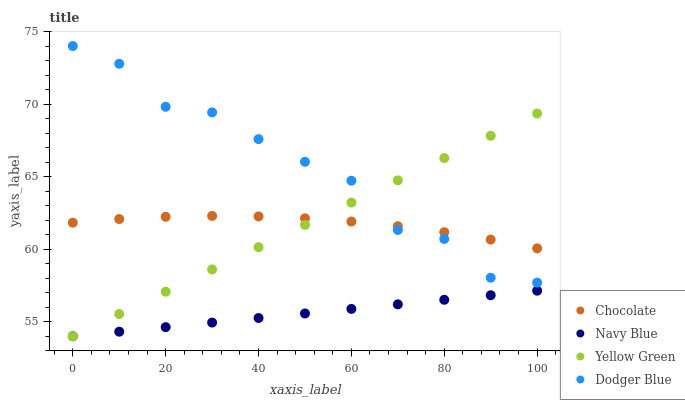Does Navy Blue have the minimum area under the curve?
Answer yes or no. Yes. Does Dodger Blue have the maximum area under the curve?
Answer yes or no. Yes. Does Yellow Green have the minimum area under the curve?
Answer yes or no. No. Does Yellow Green have the maximum area under the curve?
Answer yes or no. No. Is Yellow Green the smoothest?
Answer yes or no. Yes. Is Dodger Blue the roughest?
Answer yes or no. Yes. Is Dodger Blue the smoothest?
Answer yes or no. No. Is Yellow Green the roughest?
Answer yes or no. No. Does Navy Blue have the lowest value?
Answer yes or no. Yes. Does Dodger Blue have the lowest value?
Answer yes or no. No. Does Dodger Blue have the highest value?
Answer yes or no. Yes. Does Yellow Green have the highest value?
Answer yes or no. No. Is Navy Blue less than Dodger Blue?
Answer yes or no. Yes. Is Chocolate greater than Navy Blue?
Answer yes or no. Yes. Does Chocolate intersect Dodger Blue?
Answer yes or no. Yes. Is Chocolate less than Dodger Blue?
Answer yes or no. No. Is Chocolate greater than Dodger Blue?
Answer yes or no. No. Does Navy Blue intersect Dodger Blue?
Answer yes or no. No. 